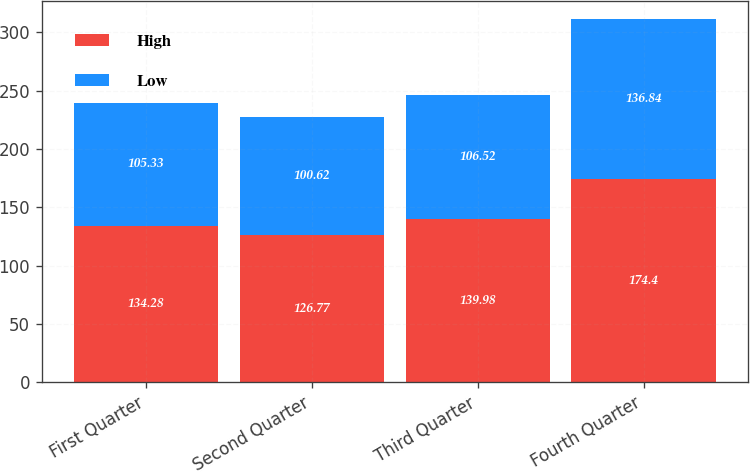Convert chart. <chart><loc_0><loc_0><loc_500><loc_500><stacked_bar_chart><ecel><fcel>First Quarter<fcel>Second Quarter<fcel>Third Quarter<fcel>Fourth Quarter<nl><fcel>High<fcel>134.28<fcel>126.77<fcel>139.98<fcel>174.4<nl><fcel>Low<fcel>105.33<fcel>100.62<fcel>106.52<fcel>136.84<nl></chart> 